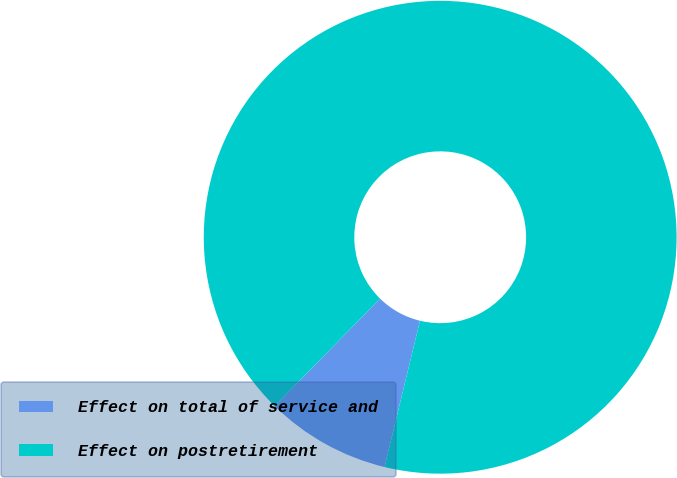<chart> <loc_0><loc_0><loc_500><loc_500><pie_chart><fcel>Effect on total of service and<fcel>Effect on postretirement<nl><fcel>8.56%<fcel>91.44%<nl></chart> 